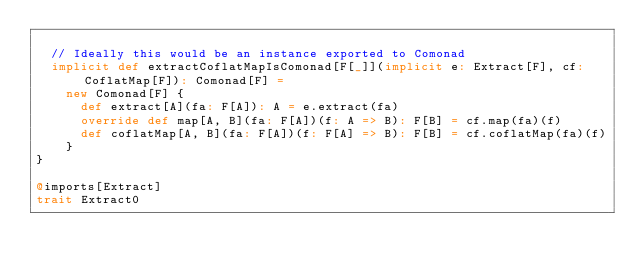Convert code to text. <code><loc_0><loc_0><loc_500><loc_500><_Scala_>
  // Ideally this would be an instance exported to Comonad
  implicit def extractCoflatMapIsComonad[F[_]](implicit e: Extract[F], cf: CoflatMap[F]): Comonad[F] =
    new Comonad[F] {
      def extract[A](fa: F[A]): A = e.extract(fa)
      override def map[A, B](fa: F[A])(f: A => B): F[B] = cf.map(fa)(f)
      def coflatMap[A, B](fa: F[A])(f: F[A] => B): F[B] = cf.coflatMap(fa)(f)
    }
}

@imports[Extract]
trait Extract0
</code> 